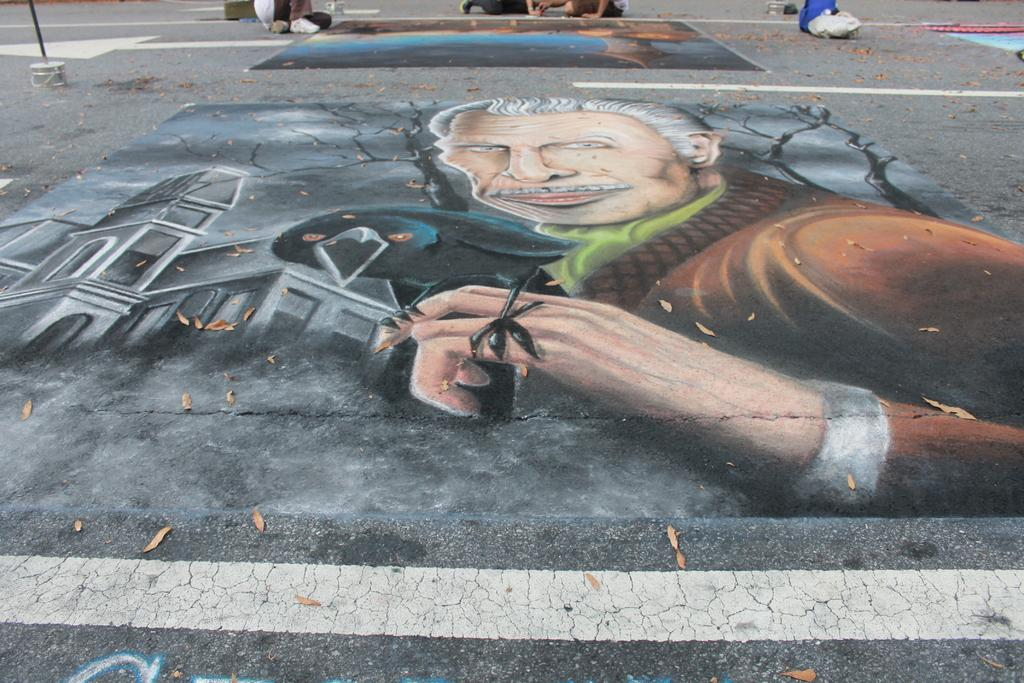What is unusual about the road in the image? There are paintings on the road in the image. What can be seen in the distance in the image? There are people visible in the background of the image. What objects are present in the background of the image? There is a bucket and a brush in the background of the image. What type of quiver can be seen in the image? There is no quiver present in the image. What action is the wax performing in the image? There is no wax present in the image, so it cannot perform any action. 